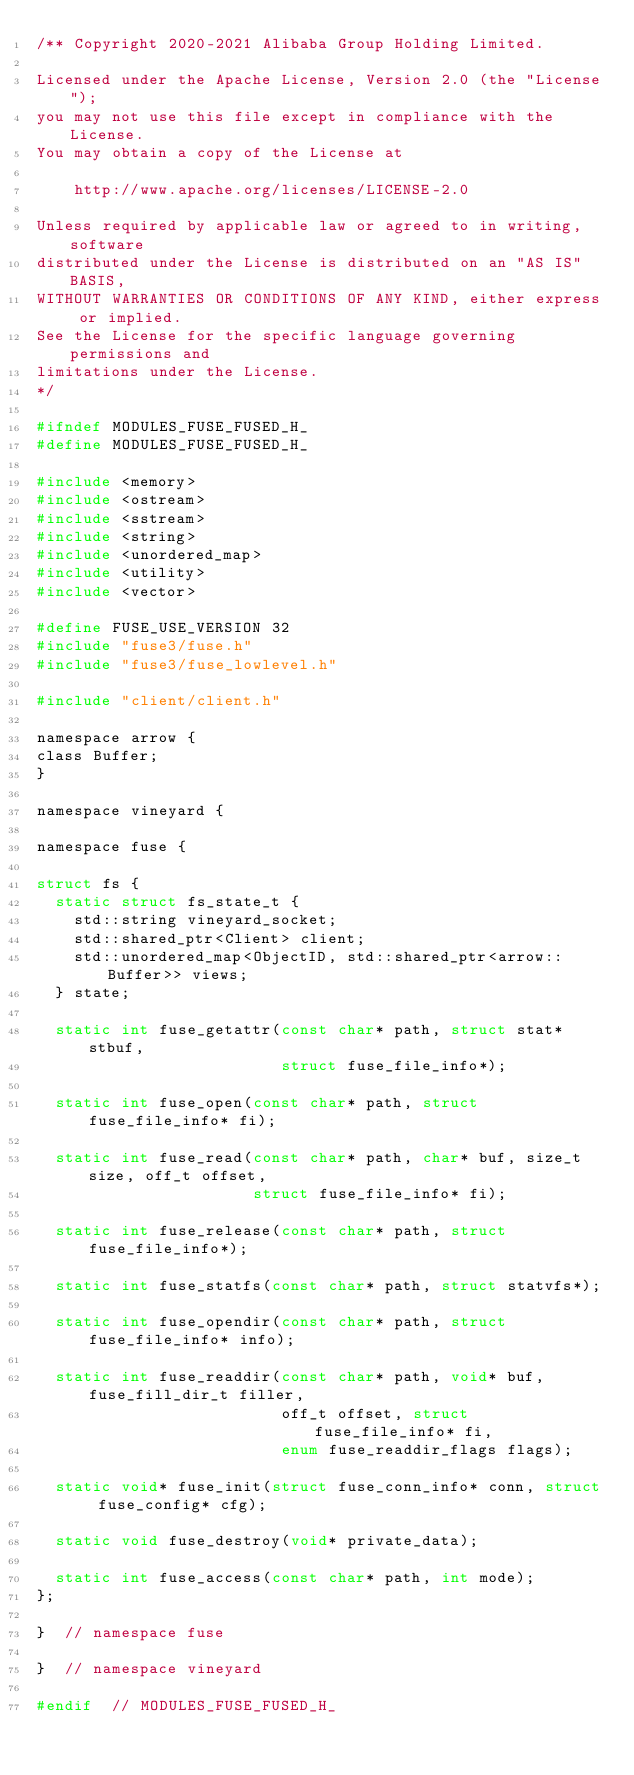Convert code to text. <code><loc_0><loc_0><loc_500><loc_500><_C_>/** Copyright 2020-2021 Alibaba Group Holding Limited.

Licensed under the Apache License, Version 2.0 (the "License");
you may not use this file except in compliance with the License.
You may obtain a copy of the License at

    http://www.apache.org/licenses/LICENSE-2.0

Unless required by applicable law or agreed to in writing, software
distributed under the License is distributed on an "AS IS" BASIS,
WITHOUT WARRANTIES OR CONDITIONS OF ANY KIND, either express or implied.
See the License for the specific language governing permissions and
limitations under the License.
*/

#ifndef MODULES_FUSE_FUSED_H_
#define MODULES_FUSE_FUSED_H_

#include <memory>
#include <ostream>
#include <sstream>
#include <string>
#include <unordered_map>
#include <utility>
#include <vector>

#define FUSE_USE_VERSION 32
#include "fuse3/fuse.h"
#include "fuse3/fuse_lowlevel.h"

#include "client/client.h"

namespace arrow {
class Buffer;
}

namespace vineyard {

namespace fuse {

struct fs {
  static struct fs_state_t {
    std::string vineyard_socket;
    std::shared_ptr<Client> client;
    std::unordered_map<ObjectID, std::shared_ptr<arrow::Buffer>> views;
  } state;

  static int fuse_getattr(const char* path, struct stat* stbuf,
                          struct fuse_file_info*);

  static int fuse_open(const char* path, struct fuse_file_info* fi);

  static int fuse_read(const char* path, char* buf, size_t size, off_t offset,
                       struct fuse_file_info* fi);

  static int fuse_release(const char* path, struct fuse_file_info*);

  static int fuse_statfs(const char* path, struct statvfs*);

  static int fuse_opendir(const char* path, struct fuse_file_info* info);

  static int fuse_readdir(const char* path, void* buf, fuse_fill_dir_t filler,
                          off_t offset, struct fuse_file_info* fi,
                          enum fuse_readdir_flags flags);

  static void* fuse_init(struct fuse_conn_info* conn, struct fuse_config* cfg);

  static void fuse_destroy(void* private_data);

  static int fuse_access(const char* path, int mode);
};

}  // namespace fuse

}  // namespace vineyard

#endif  // MODULES_FUSE_FUSED_H_
</code> 